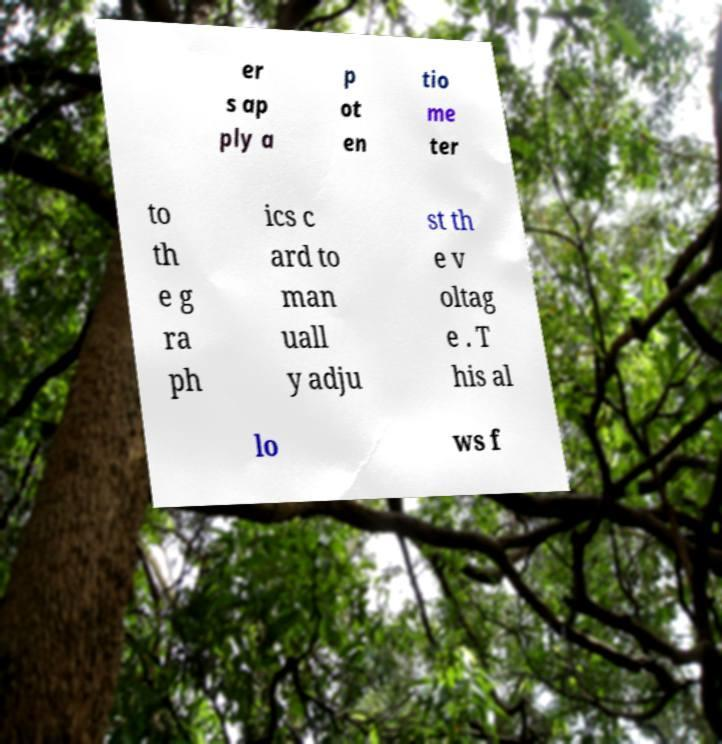What messages or text are displayed in this image? I need them in a readable, typed format. er s ap ply a p ot en tio me ter to th e g ra ph ics c ard to man uall y adju st th e v oltag e . T his al lo ws f 